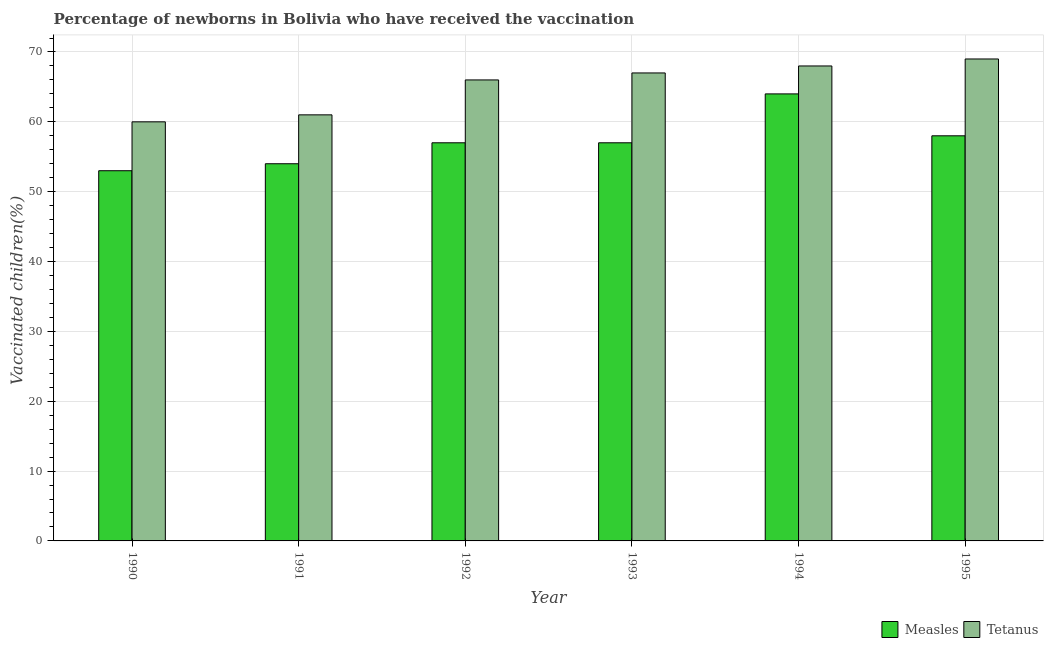How many groups of bars are there?
Provide a short and direct response. 6. Are the number of bars on each tick of the X-axis equal?
Ensure brevity in your answer.  Yes. What is the label of the 3rd group of bars from the left?
Make the answer very short. 1992. What is the percentage of newborns who received vaccination for measles in 1991?
Give a very brief answer. 54. Across all years, what is the maximum percentage of newborns who received vaccination for measles?
Give a very brief answer. 64. Across all years, what is the minimum percentage of newborns who received vaccination for measles?
Ensure brevity in your answer.  53. In which year was the percentage of newborns who received vaccination for measles maximum?
Provide a succinct answer. 1994. What is the total percentage of newborns who received vaccination for measles in the graph?
Give a very brief answer. 343. What is the difference between the percentage of newborns who received vaccination for measles in 1992 and that in 1995?
Your answer should be compact. -1. What is the average percentage of newborns who received vaccination for measles per year?
Keep it short and to the point. 57.17. In how many years, is the percentage of newborns who received vaccination for measles greater than 54 %?
Ensure brevity in your answer.  4. What is the ratio of the percentage of newborns who received vaccination for tetanus in 1990 to that in 1995?
Your answer should be very brief. 0.87. Is the difference between the percentage of newborns who received vaccination for tetanus in 1993 and 1995 greater than the difference between the percentage of newborns who received vaccination for measles in 1993 and 1995?
Your answer should be very brief. No. What is the difference between the highest and the lowest percentage of newborns who received vaccination for measles?
Your response must be concise. 11. Is the sum of the percentage of newborns who received vaccination for tetanus in 1990 and 1995 greater than the maximum percentage of newborns who received vaccination for measles across all years?
Provide a short and direct response. Yes. What does the 1st bar from the left in 1990 represents?
Provide a succinct answer. Measles. What does the 1st bar from the right in 1990 represents?
Provide a short and direct response. Tetanus. How many bars are there?
Your answer should be very brief. 12. What is the difference between two consecutive major ticks on the Y-axis?
Make the answer very short. 10. Are the values on the major ticks of Y-axis written in scientific E-notation?
Offer a terse response. No. Does the graph contain any zero values?
Your response must be concise. No. What is the title of the graph?
Your answer should be compact. Percentage of newborns in Bolivia who have received the vaccination. What is the label or title of the X-axis?
Give a very brief answer. Year. What is the label or title of the Y-axis?
Give a very brief answer. Vaccinated children(%)
. What is the Vaccinated children(%)
 in Measles in 1991?
Your answer should be compact. 54. What is the Vaccinated children(%)
 in Measles in 1992?
Keep it short and to the point. 57. What is the Vaccinated children(%)
 of Tetanus in 1992?
Give a very brief answer. 66. What is the Vaccinated children(%)
 of Tetanus in 1994?
Your answer should be compact. 68. What is the Vaccinated children(%)
 in Tetanus in 1995?
Your answer should be compact. 69. Across all years, what is the maximum Vaccinated children(%)
 in Measles?
Your answer should be compact. 64. Across all years, what is the minimum Vaccinated children(%)
 of Measles?
Keep it short and to the point. 53. Across all years, what is the minimum Vaccinated children(%)
 in Tetanus?
Provide a short and direct response. 60. What is the total Vaccinated children(%)
 in Measles in the graph?
Provide a short and direct response. 343. What is the total Vaccinated children(%)
 in Tetanus in the graph?
Your answer should be compact. 391. What is the difference between the Vaccinated children(%)
 of Measles in 1990 and that in 1992?
Keep it short and to the point. -4. What is the difference between the Vaccinated children(%)
 of Tetanus in 1990 and that in 1992?
Make the answer very short. -6. What is the difference between the Vaccinated children(%)
 in Tetanus in 1990 and that in 1993?
Provide a short and direct response. -7. What is the difference between the Vaccinated children(%)
 of Measles in 1990 and that in 1994?
Give a very brief answer. -11. What is the difference between the Vaccinated children(%)
 of Tetanus in 1990 and that in 1995?
Make the answer very short. -9. What is the difference between the Vaccinated children(%)
 in Tetanus in 1992 and that in 1993?
Provide a short and direct response. -1. What is the difference between the Vaccinated children(%)
 in Measles in 1992 and that in 1994?
Offer a very short reply. -7. What is the difference between the Vaccinated children(%)
 in Tetanus in 1993 and that in 1995?
Provide a succinct answer. -2. What is the difference between the Vaccinated children(%)
 of Measles in 1994 and that in 1995?
Your answer should be compact. 6. What is the difference between the Vaccinated children(%)
 of Measles in 1990 and the Vaccinated children(%)
 of Tetanus in 1991?
Your answer should be compact. -8. What is the difference between the Vaccinated children(%)
 of Measles in 1990 and the Vaccinated children(%)
 of Tetanus in 1992?
Give a very brief answer. -13. What is the difference between the Vaccinated children(%)
 of Measles in 1991 and the Vaccinated children(%)
 of Tetanus in 1992?
Ensure brevity in your answer.  -12. What is the difference between the Vaccinated children(%)
 in Measles in 1992 and the Vaccinated children(%)
 in Tetanus in 1993?
Provide a succinct answer. -10. What is the difference between the Vaccinated children(%)
 of Measles in 1992 and the Vaccinated children(%)
 of Tetanus in 1994?
Your answer should be very brief. -11. What is the difference between the Vaccinated children(%)
 of Measles in 1992 and the Vaccinated children(%)
 of Tetanus in 1995?
Your response must be concise. -12. What is the difference between the Vaccinated children(%)
 of Measles in 1994 and the Vaccinated children(%)
 of Tetanus in 1995?
Your answer should be compact. -5. What is the average Vaccinated children(%)
 of Measles per year?
Your answer should be very brief. 57.17. What is the average Vaccinated children(%)
 of Tetanus per year?
Keep it short and to the point. 65.17. In the year 1991, what is the difference between the Vaccinated children(%)
 of Measles and Vaccinated children(%)
 of Tetanus?
Make the answer very short. -7. In the year 1993, what is the difference between the Vaccinated children(%)
 in Measles and Vaccinated children(%)
 in Tetanus?
Your response must be concise. -10. What is the ratio of the Vaccinated children(%)
 of Measles in 1990 to that in 1991?
Keep it short and to the point. 0.98. What is the ratio of the Vaccinated children(%)
 in Tetanus in 1990 to that in 1991?
Offer a terse response. 0.98. What is the ratio of the Vaccinated children(%)
 of Measles in 1990 to that in 1992?
Give a very brief answer. 0.93. What is the ratio of the Vaccinated children(%)
 of Measles in 1990 to that in 1993?
Keep it short and to the point. 0.93. What is the ratio of the Vaccinated children(%)
 in Tetanus in 1990 to that in 1993?
Ensure brevity in your answer.  0.9. What is the ratio of the Vaccinated children(%)
 of Measles in 1990 to that in 1994?
Provide a succinct answer. 0.83. What is the ratio of the Vaccinated children(%)
 in Tetanus in 1990 to that in 1994?
Your response must be concise. 0.88. What is the ratio of the Vaccinated children(%)
 in Measles in 1990 to that in 1995?
Keep it short and to the point. 0.91. What is the ratio of the Vaccinated children(%)
 in Tetanus in 1990 to that in 1995?
Give a very brief answer. 0.87. What is the ratio of the Vaccinated children(%)
 in Measles in 1991 to that in 1992?
Your answer should be very brief. 0.95. What is the ratio of the Vaccinated children(%)
 of Tetanus in 1991 to that in 1992?
Give a very brief answer. 0.92. What is the ratio of the Vaccinated children(%)
 in Tetanus in 1991 to that in 1993?
Provide a succinct answer. 0.91. What is the ratio of the Vaccinated children(%)
 in Measles in 1991 to that in 1994?
Give a very brief answer. 0.84. What is the ratio of the Vaccinated children(%)
 in Tetanus in 1991 to that in 1994?
Offer a terse response. 0.9. What is the ratio of the Vaccinated children(%)
 in Tetanus in 1991 to that in 1995?
Give a very brief answer. 0.88. What is the ratio of the Vaccinated children(%)
 in Measles in 1992 to that in 1993?
Your response must be concise. 1. What is the ratio of the Vaccinated children(%)
 in Tetanus in 1992 to that in 1993?
Provide a succinct answer. 0.99. What is the ratio of the Vaccinated children(%)
 of Measles in 1992 to that in 1994?
Offer a very short reply. 0.89. What is the ratio of the Vaccinated children(%)
 of Tetanus in 1992 to that in 1994?
Your answer should be compact. 0.97. What is the ratio of the Vaccinated children(%)
 of Measles in 1992 to that in 1995?
Give a very brief answer. 0.98. What is the ratio of the Vaccinated children(%)
 in Tetanus in 1992 to that in 1995?
Ensure brevity in your answer.  0.96. What is the ratio of the Vaccinated children(%)
 of Measles in 1993 to that in 1994?
Give a very brief answer. 0.89. What is the ratio of the Vaccinated children(%)
 in Measles in 1993 to that in 1995?
Ensure brevity in your answer.  0.98. What is the ratio of the Vaccinated children(%)
 of Tetanus in 1993 to that in 1995?
Offer a very short reply. 0.97. What is the ratio of the Vaccinated children(%)
 in Measles in 1994 to that in 1995?
Provide a short and direct response. 1.1. What is the ratio of the Vaccinated children(%)
 of Tetanus in 1994 to that in 1995?
Your response must be concise. 0.99. What is the difference between the highest and the lowest Vaccinated children(%)
 in Measles?
Make the answer very short. 11. What is the difference between the highest and the lowest Vaccinated children(%)
 in Tetanus?
Ensure brevity in your answer.  9. 